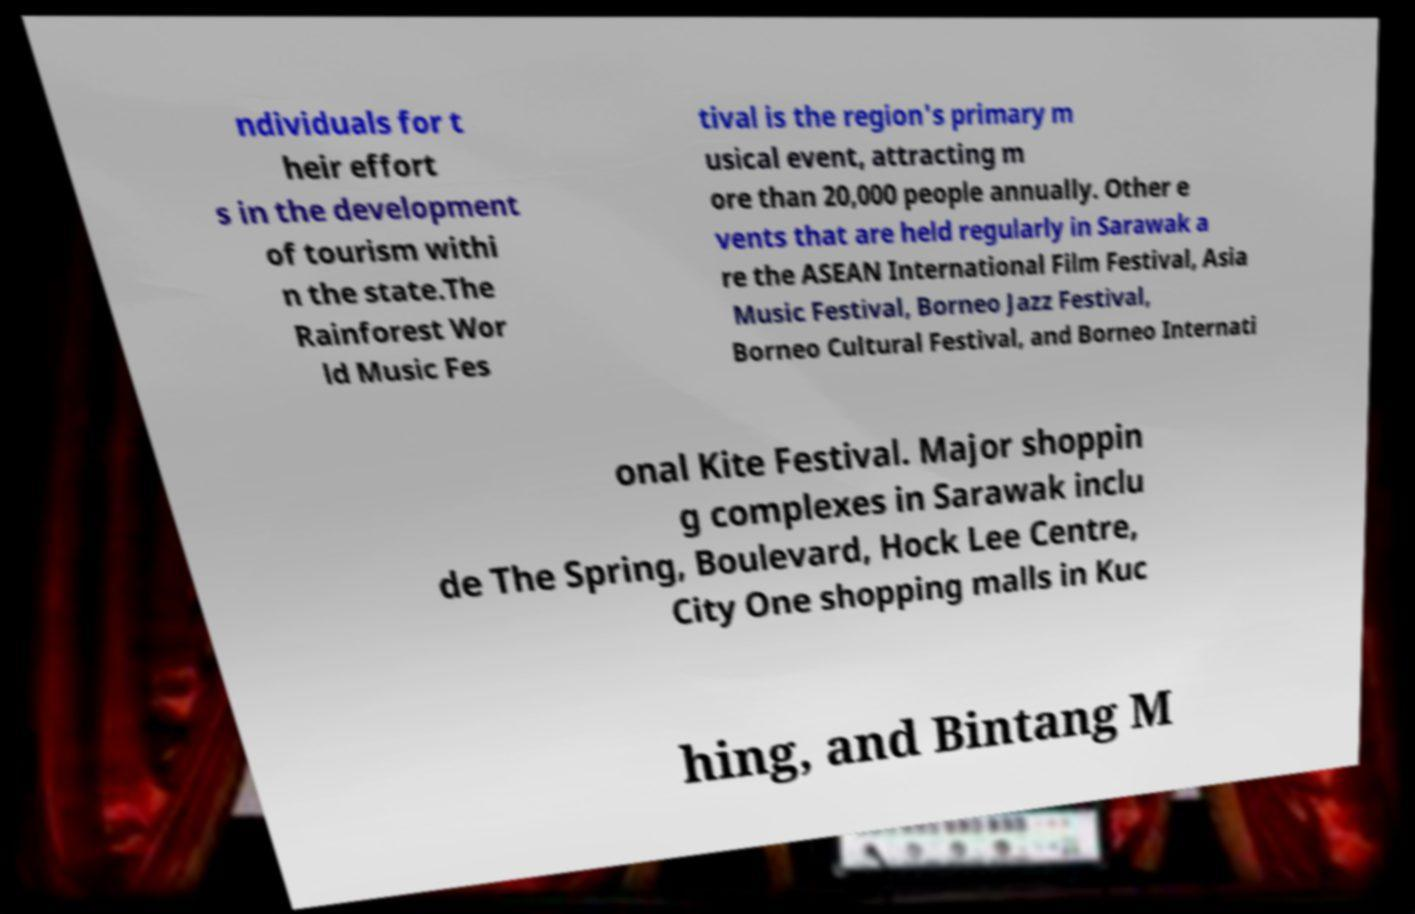Could you assist in decoding the text presented in this image and type it out clearly? ndividuals for t heir effort s in the development of tourism withi n the state.The Rainforest Wor ld Music Fes tival is the region's primary m usical event, attracting m ore than 20,000 people annually. Other e vents that are held regularly in Sarawak a re the ASEAN International Film Festival, Asia Music Festival, Borneo Jazz Festival, Borneo Cultural Festival, and Borneo Internati onal Kite Festival. Major shoppin g complexes in Sarawak inclu de The Spring, Boulevard, Hock Lee Centre, City One shopping malls in Kuc hing, and Bintang M 